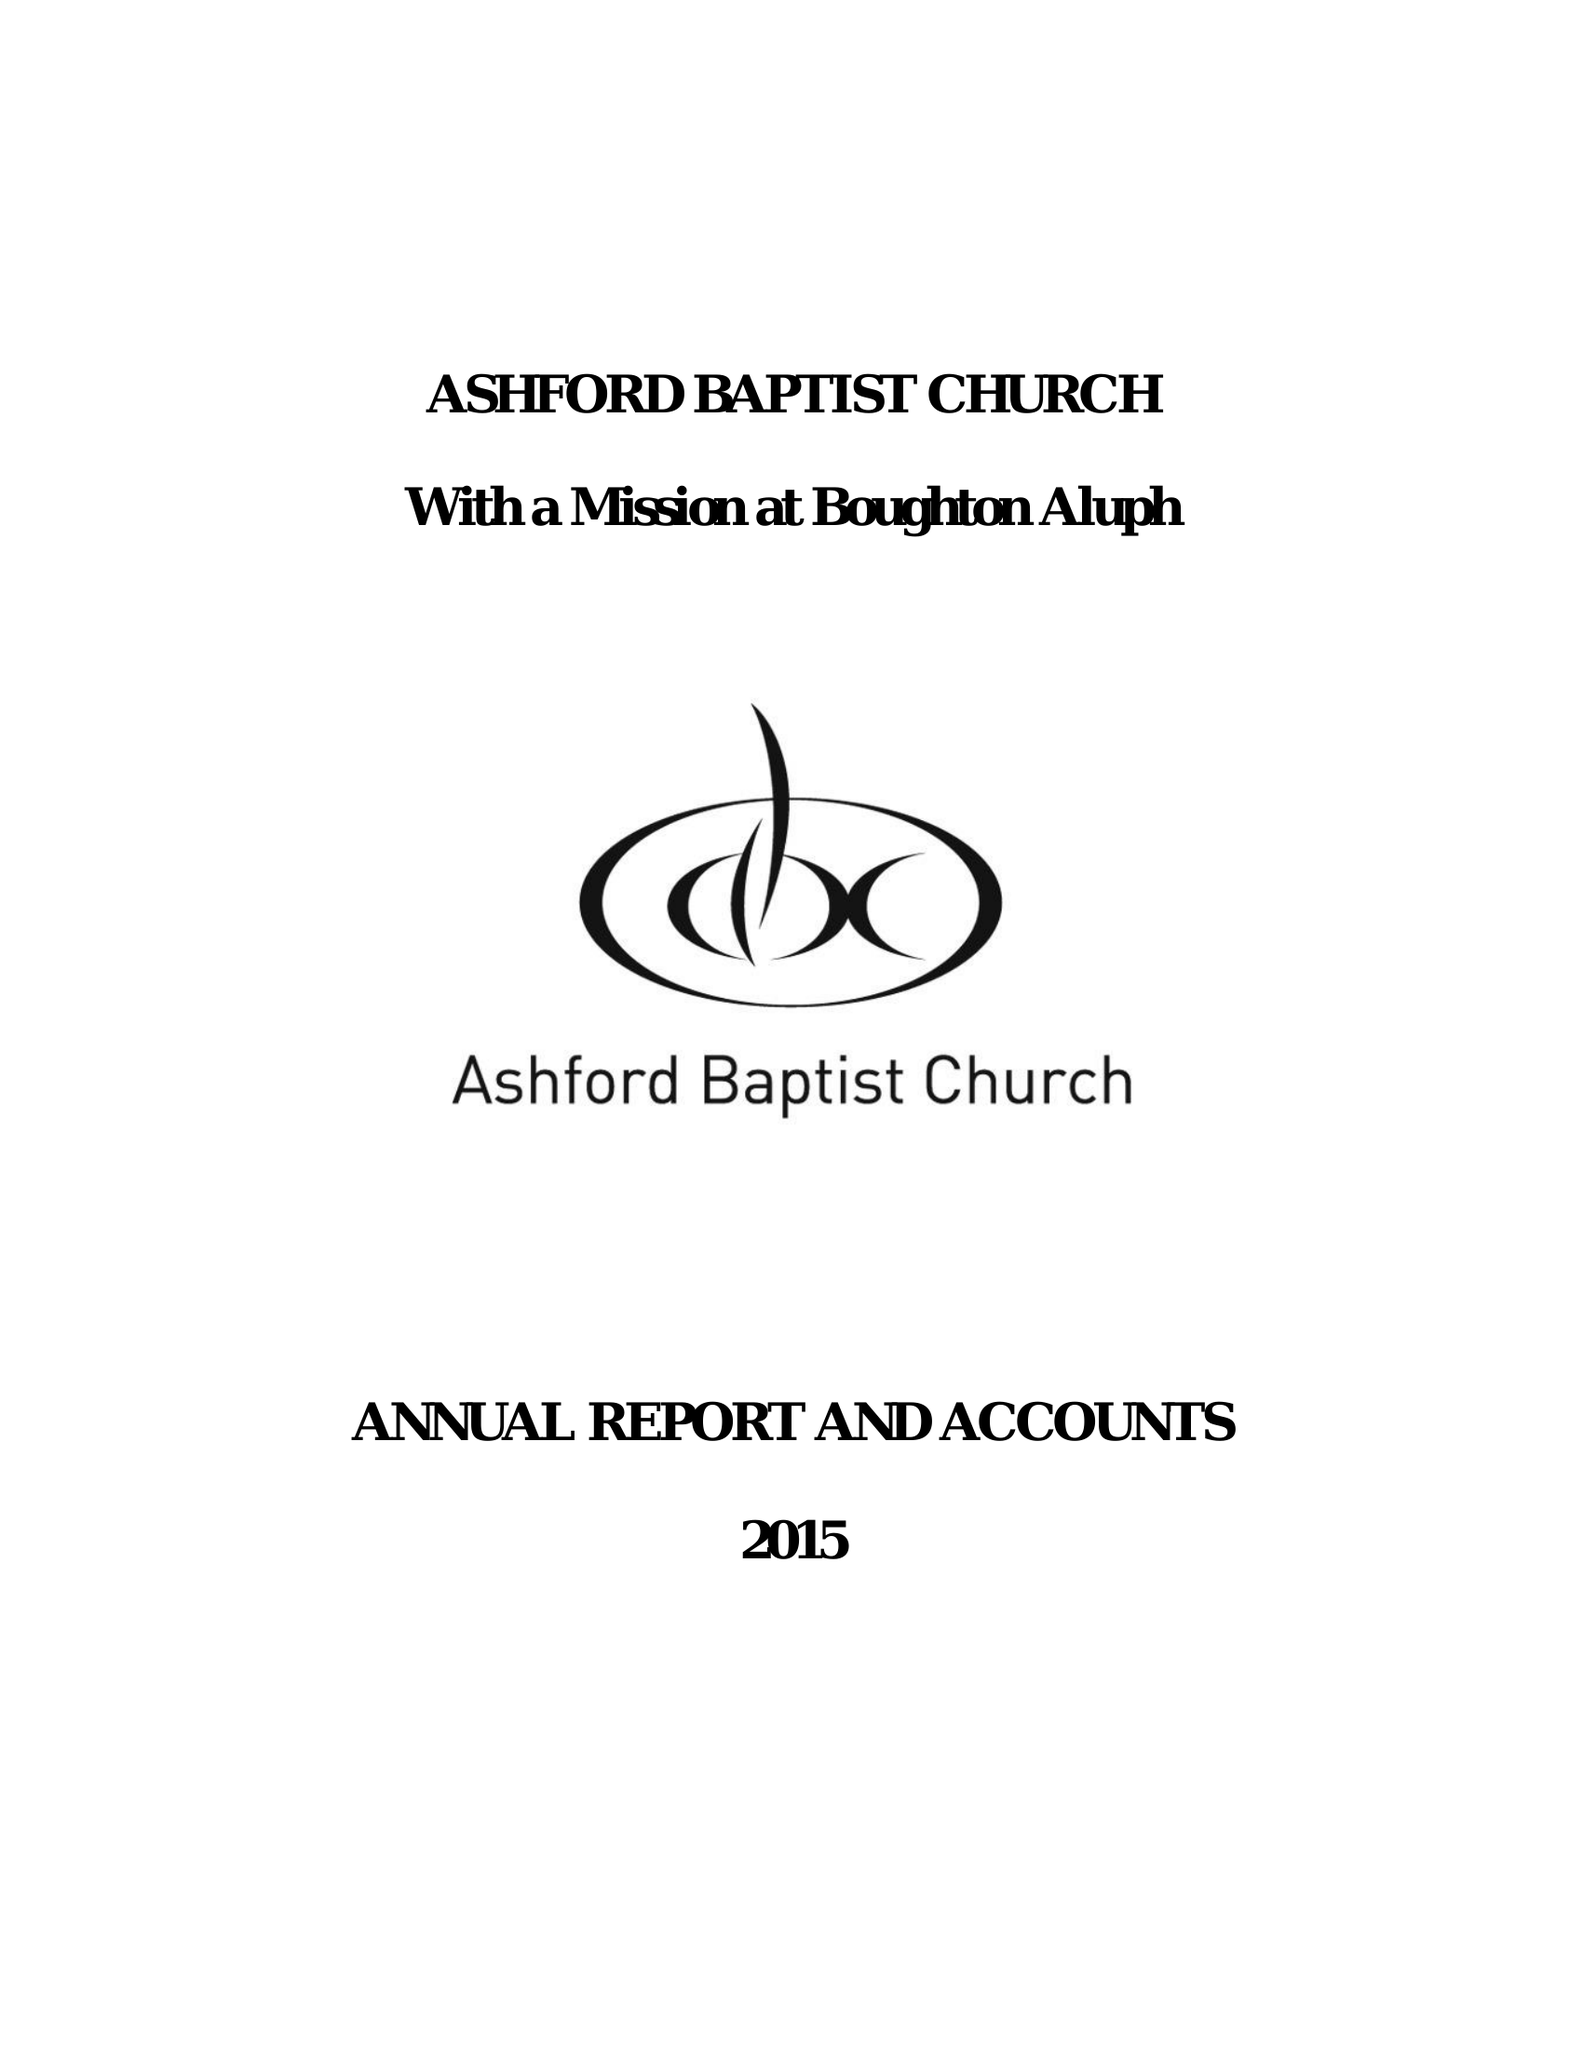What is the value for the charity_name?
Answer the question using a single word or phrase. Ashford Baptist Church 